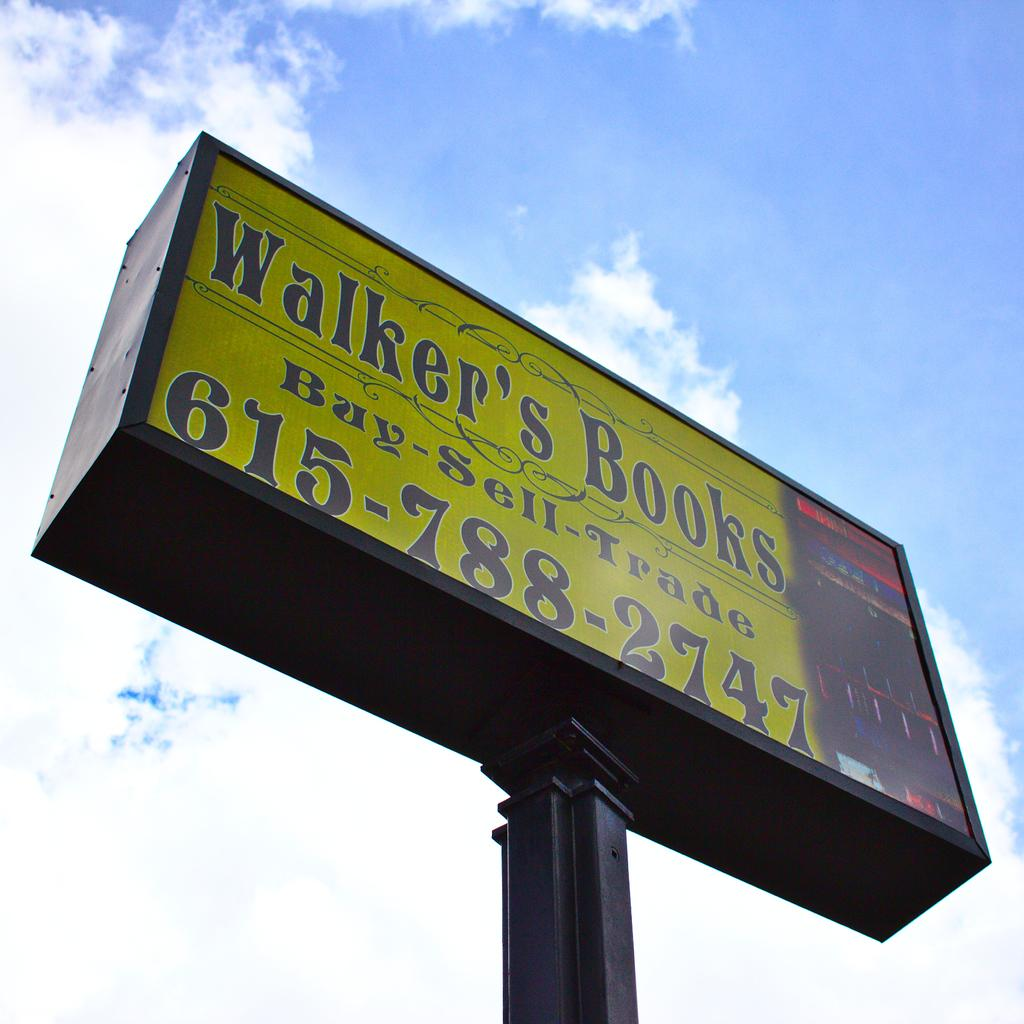<image>
Offer a succinct explanation of the picture presented. A tall billboard for Walker's Books advertising that they buy, sell, and trade books. 